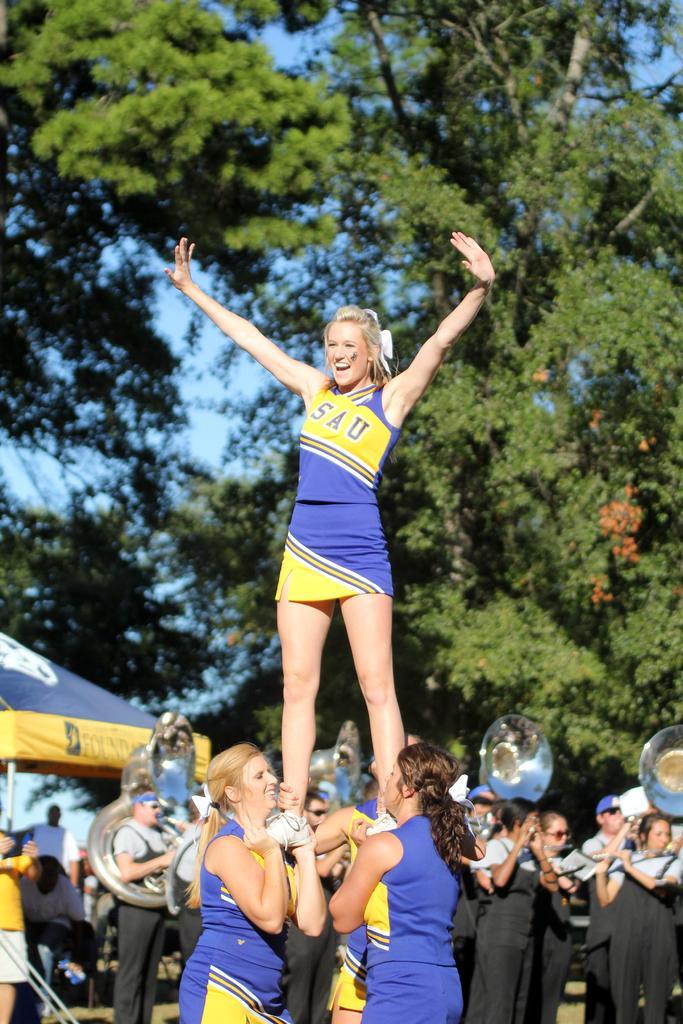Describe this image in one or two sentences. At the foreground of the image there are three women wearing similar color dress and a person standing on the other person's hands and cheer leading and at the background of the image there are some other persons who are playing musical instruments and some are standing under the tents and there are some trees and clear sky. 